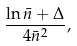Convert formula to latex. <formula><loc_0><loc_0><loc_500><loc_500>\frac { \ln \bar { n } + \Delta } { 4 \bar { n } ^ { 2 } } ,</formula> 